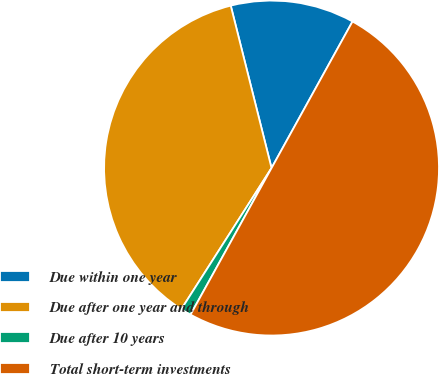Convert chart. <chart><loc_0><loc_0><loc_500><loc_500><pie_chart><fcel>Due within one year<fcel>Due after one year and through<fcel>Due after 10 years<fcel>Total short-term investments<nl><fcel>11.95%<fcel>37.03%<fcel>1.02%<fcel>50.0%<nl></chart> 